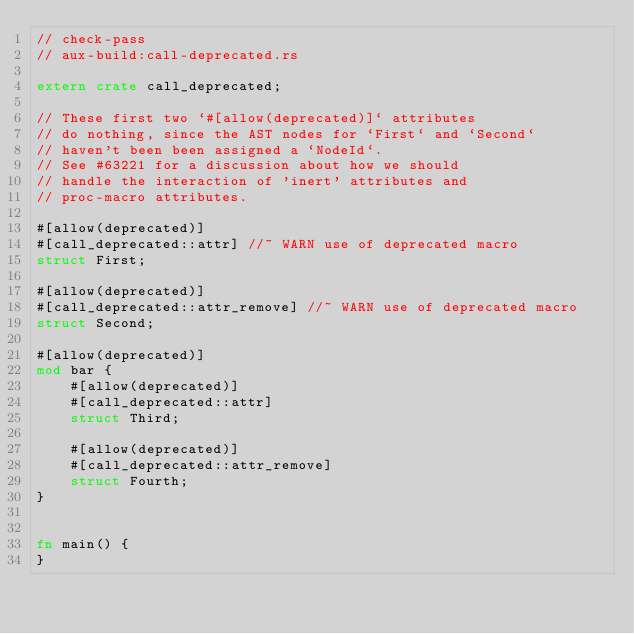Convert code to text. <code><loc_0><loc_0><loc_500><loc_500><_Rust_>// check-pass
// aux-build:call-deprecated.rs

extern crate call_deprecated;

// These first two `#[allow(deprecated)]` attributes
// do nothing, since the AST nodes for `First` and `Second`
// haven't been been assigned a `NodeId`.
// See #63221 for a discussion about how we should
// handle the interaction of 'inert' attributes and
// proc-macro attributes.

#[allow(deprecated)]
#[call_deprecated::attr] //~ WARN use of deprecated macro
struct First;

#[allow(deprecated)]
#[call_deprecated::attr_remove] //~ WARN use of deprecated macro
struct Second;

#[allow(deprecated)]
mod bar {
    #[allow(deprecated)]
    #[call_deprecated::attr]
    struct Third;

    #[allow(deprecated)]
    #[call_deprecated::attr_remove]
    struct Fourth;
}


fn main() {
}
</code> 